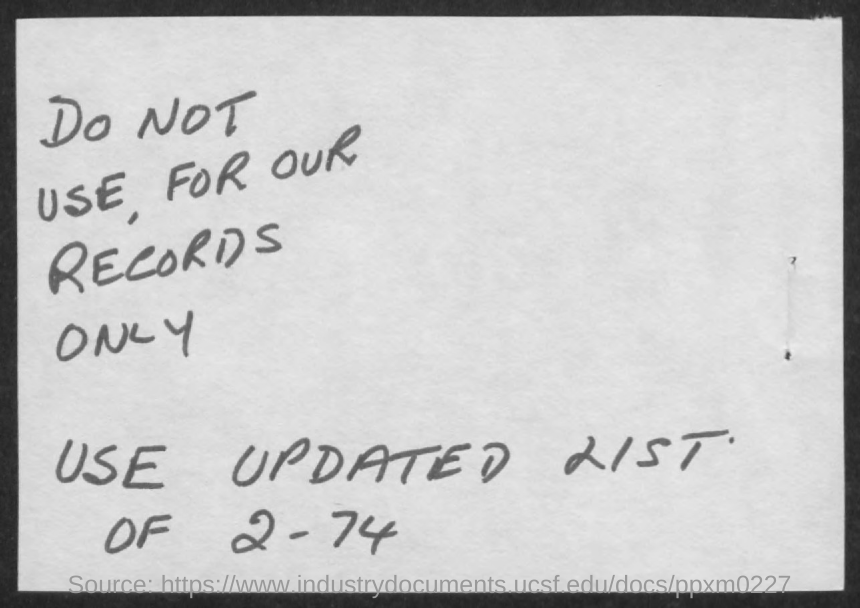List a handful of essential elements in this visual. The number mentioned in the document is 2 - 74. 